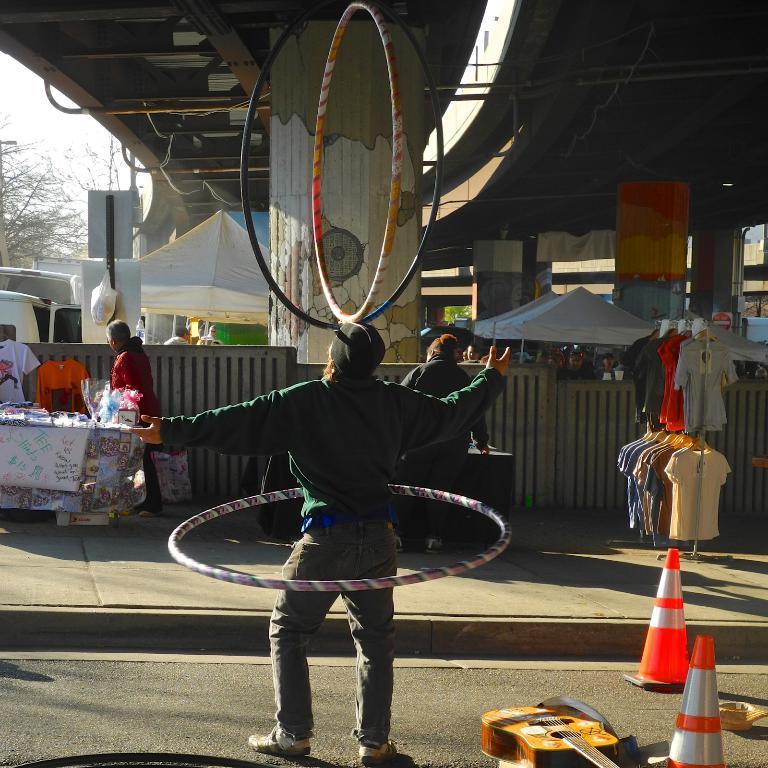Please provide a concise description of this image. There is a man standing on the road performing some activities with rings. He is wearing a green shirt. Beside him there is a guitar and two traffic cones. He is standing under the bridge. We can see a pillar here. There are some stalls on the side of the road which are on footpath. In the background we can observe trees and sky. There is a cover hanging to the board. And we can see tents which are in white colour. There are some clothes on the side of the road. There is a man standing in front of this guy who is performing activities with rings. 